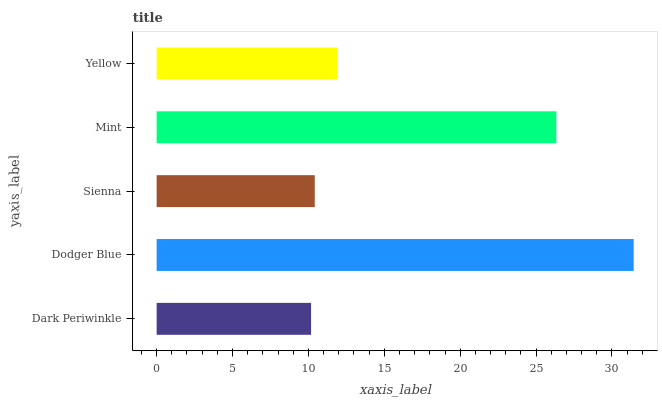Is Dark Periwinkle the minimum?
Answer yes or no. Yes. Is Dodger Blue the maximum?
Answer yes or no. Yes. Is Sienna the minimum?
Answer yes or no. No. Is Sienna the maximum?
Answer yes or no. No. Is Dodger Blue greater than Sienna?
Answer yes or no. Yes. Is Sienna less than Dodger Blue?
Answer yes or no. Yes. Is Sienna greater than Dodger Blue?
Answer yes or no. No. Is Dodger Blue less than Sienna?
Answer yes or no. No. Is Yellow the high median?
Answer yes or no. Yes. Is Yellow the low median?
Answer yes or no. Yes. Is Mint the high median?
Answer yes or no. No. Is Mint the low median?
Answer yes or no. No. 